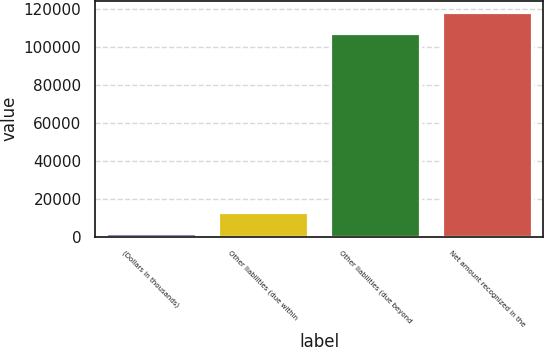Convert chart. <chart><loc_0><loc_0><loc_500><loc_500><bar_chart><fcel>(Dollars in thousands)<fcel>Other liabilities (due within<fcel>Other liabilities (due beyond<fcel>Net amount recognized in the<nl><fcel>2014<fcel>13110.2<fcel>107507<fcel>118603<nl></chart> 